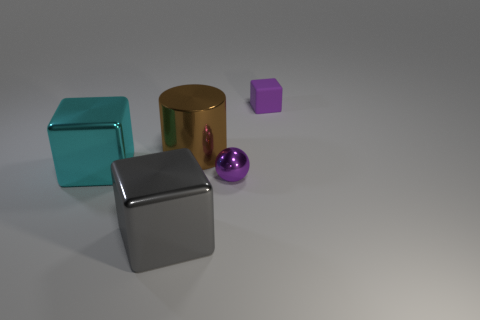How many matte objects have the same color as the metal cylinder? There are no matte objects that have the same gold color as the metal cylinder in the image. 